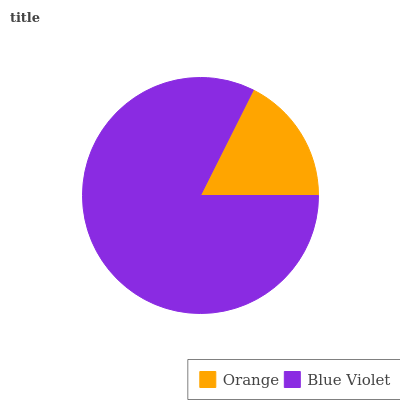Is Orange the minimum?
Answer yes or no. Yes. Is Blue Violet the maximum?
Answer yes or no. Yes. Is Blue Violet the minimum?
Answer yes or no. No. Is Blue Violet greater than Orange?
Answer yes or no. Yes. Is Orange less than Blue Violet?
Answer yes or no. Yes. Is Orange greater than Blue Violet?
Answer yes or no. No. Is Blue Violet less than Orange?
Answer yes or no. No. Is Blue Violet the high median?
Answer yes or no. Yes. Is Orange the low median?
Answer yes or no. Yes. Is Orange the high median?
Answer yes or no. No. Is Blue Violet the low median?
Answer yes or no. No. 